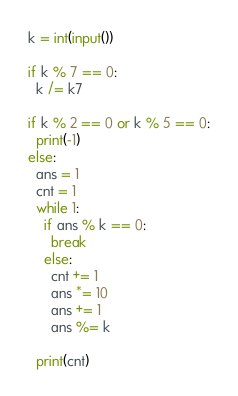Convert code to text. <code><loc_0><loc_0><loc_500><loc_500><_Python_>k = int(input())

if k % 7 == 0:
  k /= k7

if k % 2 == 0 or k % 5 == 0:
  print(-1)
else:
  ans = 1
  cnt = 1
  while 1:
    if ans % k == 0:
      break
    else:
      cnt += 1
      ans *= 10
      ans += 1
      ans %= k

  print(cnt)      </code> 